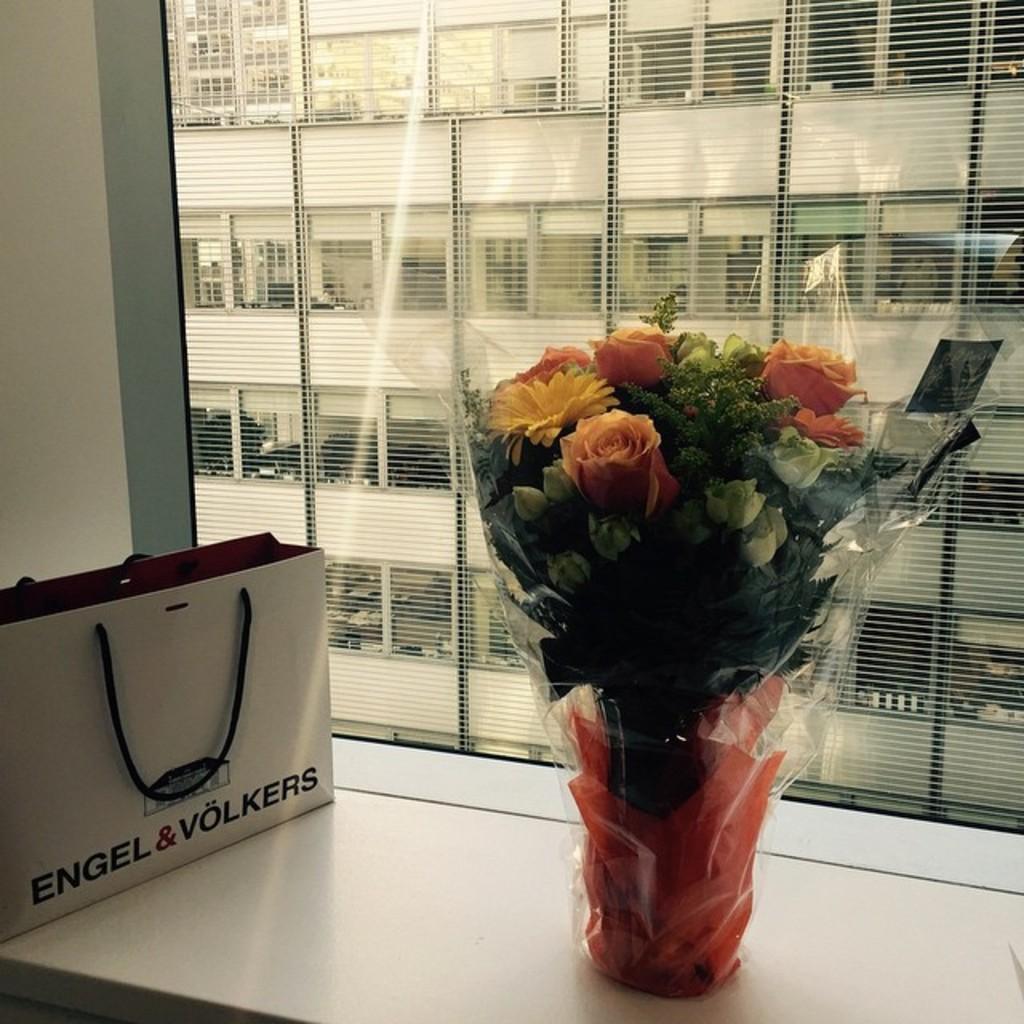Can you describe this image briefly? There is a white surface. On that there is a cover and a flower bouquet. In the back there is a window. Through the window we can see a building with pillars. 